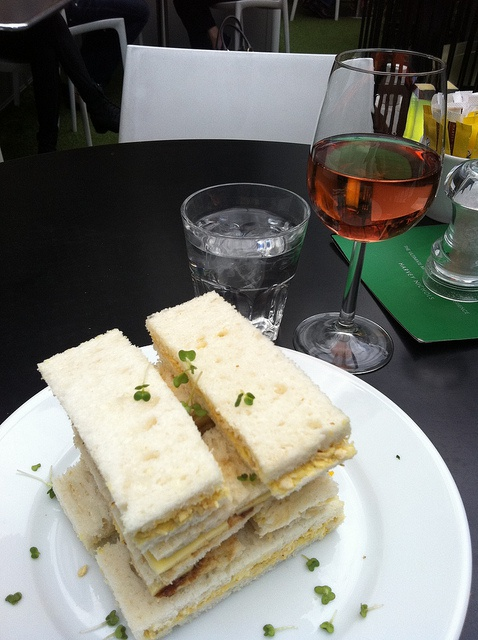Describe the objects in this image and their specific colors. I can see dining table in black, ivory, gray, and darkgray tones, sandwich in black, beige, and tan tones, wine glass in black, gray, darkgray, and maroon tones, chair in black, darkgray, and lightgray tones, and cup in black, gray, darkgray, and lightgray tones in this image. 